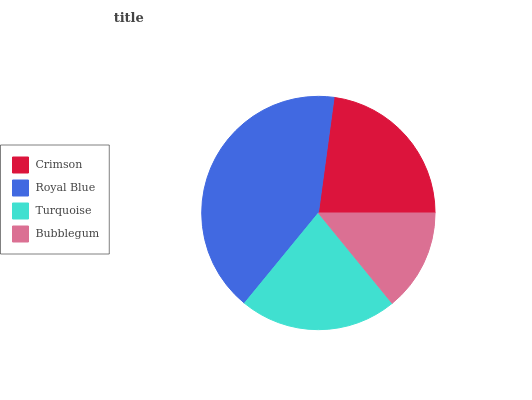Is Bubblegum the minimum?
Answer yes or no. Yes. Is Royal Blue the maximum?
Answer yes or no. Yes. Is Turquoise the minimum?
Answer yes or no. No. Is Turquoise the maximum?
Answer yes or no. No. Is Royal Blue greater than Turquoise?
Answer yes or no. Yes. Is Turquoise less than Royal Blue?
Answer yes or no. Yes. Is Turquoise greater than Royal Blue?
Answer yes or no. No. Is Royal Blue less than Turquoise?
Answer yes or no. No. Is Crimson the high median?
Answer yes or no. Yes. Is Turquoise the low median?
Answer yes or no. Yes. Is Royal Blue the high median?
Answer yes or no. No. Is Bubblegum the low median?
Answer yes or no. No. 